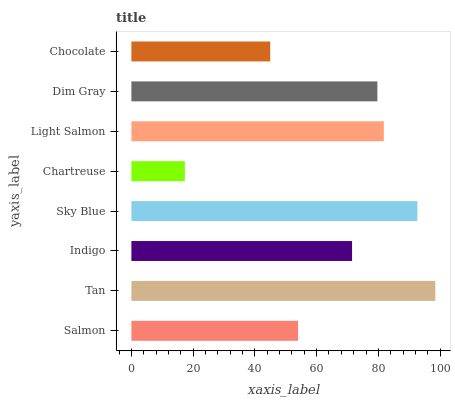Is Chartreuse the minimum?
Answer yes or no. Yes. Is Tan the maximum?
Answer yes or no. Yes. Is Indigo the minimum?
Answer yes or no. No. Is Indigo the maximum?
Answer yes or no. No. Is Tan greater than Indigo?
Answer yes or no. Yes. Is Indigo less than Tan?
Answer yes or no. Yes. Is Indigo greater than Tan?
Answer yes or no. No. Is Tan less than Indigo?
Answer yes or no. No. Is Dim Gray the high median?
Answer yes or no. Yes. Is Indigo the low median?
Answer yes or no. Yes. Is Sky Blue the high median?
Answer yes or no. No. Is Salmon the low median?
Answer yes or no. No. 